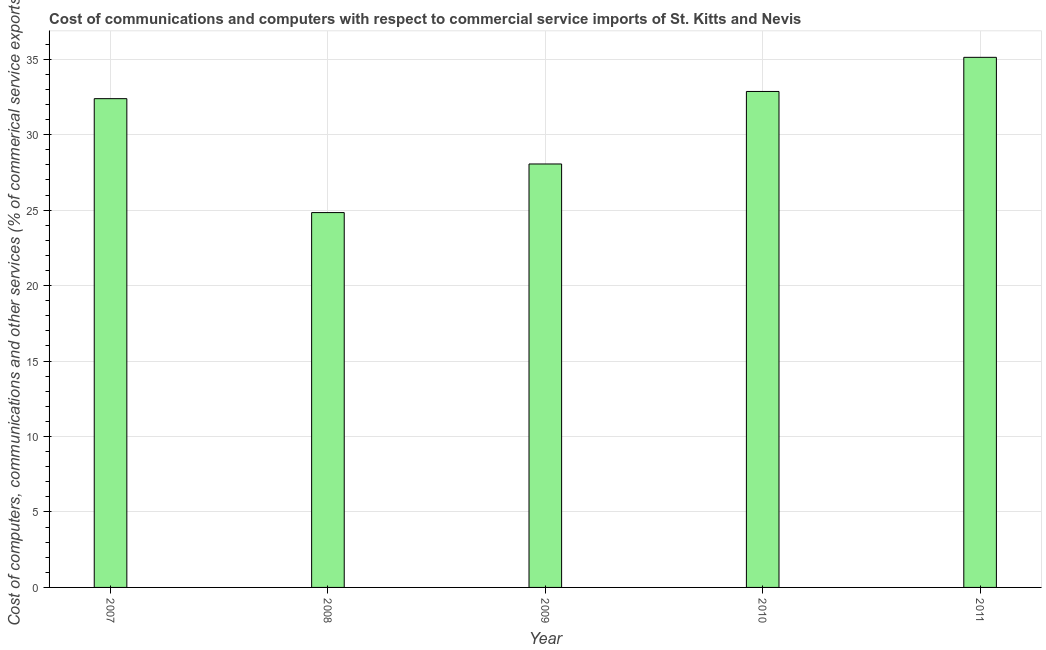What is the title of the graph?
Give a very brief answer. Cost of communications and computers with respect to commercial service imports of St. Kitts and Nevis. What is the label or title of the X-axis?
Your answer should be compact. Year. What is the label or title of the Y-axis?
Provide a succinct answer. Cost of computers, communications and other services (% of commerical service exports). What is the  computer and other services in 2011?
Make the answer very short. 35.12. Across all years, what is the maximum  computer and other services?
Give a very brief answer. 35.12. Across all years, what is the minimum  computer and other services?
Offer a very short reply. 24.84. In which year was the  computer and other services minimum?
Your answer should be compact. 2008. What is the sum of the  computer and other services?
Your answer should be very brief. 153.25. What is the difference between the cost of communications in 2008 and 2011?
Your response must be concise. -10.29. What is the average cost of communications per year?
Offer a terse response. 30.65. What is the median cost of communications?
Provide a short and direct response. 32.38. In how many years, is the  computer and other services greater than 24 %?
Your response must be concise. 5. What is the ratio of the  computer and other services in 2008 to that in 2011?
Make the answer very short. 0.71. Is the difference between the  computer and other services in 2008 and 2011 greater than the difference between any two years?
Keep it short and to the point. Yes. What is the difference between the highest and the second highest cost of communications?
Ensure brevity in your answer.  2.26. What is the difference between the highest and the lowest cost of communications?
Your answer should be compact. 10.29. How many bars are there?
Your answer should be compact. 5. Are all the bars in the graph horizontal?
Make the answer very short. No. How many years are there in the graph?
Keep it short and to the point. 5. What is the difference between two consecutive major ticks on the Y-axis?
Provide a short and direct response. 5. Are the values on the major ticks of Y-axis written in scientific E-notation?
Offer a very short reply. No. What is the Cost of computers, communications and other services (% of commerical service exports) of 2007?
Your answer should be compact. 32.38. What is the Cost of computers, communications and other services (% of commerical service exports) of 2008?
Your answer should be very brief. 24.84. What is the Cost of computers, communications and other services (% of commerical service exports) in 2009?
Give a very brief answer. 28.06. What is the Cost of computers, communications and other services (% of commerical service exports) in 2010?
Ensure brevity in your answer.  32.86. What is the Cost of computers, communications and other services (% of commerical service exports) in 2011?
Provide a short and direct response. 35.12. What is the difference between the Cost of computers, communications and other services (% of commerical service exports) in 2007 and 2008?
Your answer should be very brief. 7.55. What is the difference between the Cost of computers, communications and other services (% of commerical service exports) in 2007 and 2009?
Give a very brief answer. 4.33. What is the difference between the Cost of computers, communications and other services (% of commerical service exports) in 2007 and 2010?
Your answer should be compact. -0.48. What is the difference between the Cost of computers, communications and other services (% of commerical service exports) in 2007 and 2011?
Your response must be concise. -2.74. What is the difference between the Cost of computers, communications and other services (% of commerical service exports) in 2008 and 2009?
Provide a short and direct response. -3.22. What is the difference between the Cost of computers, communications and other services (% of commerical service exports) in 2008 and 2010?
Provide a succinct answer. -8.03. What is the difference between the Cost of computers, communications and other services (% of commerical service exports) in 2008 and 2011?
Offer a very short reply. -10.29. What is the difference between the Cost of computers, communications and other services (% of commerical service exports) in 2009 and 2010?
Offer a very short reply. -4.8. What is the difference between the Cost of computers, communications and other services (% of commerical service exports) in 2009 and 2011?
Offer a very short reply. -7.07. What is the difference between the Cost of computers, communications and other services (% of commerical service exports) in 2010 and 2011?
Offer a terse response. -2.26. What is the ratio of the Cost of computers, communications and other services (% of commerical service exports) in 2007 to that in 2008?
Your response must be concise. 1.3. What is the ratio of the Cost of computers, communications and other services (% of commerical service exports) in 2007 to that in 2009?
Make the answer very short. 1.15. What is the ratio of the Cost of computers, communications and other services (% of commerical service exports) in 2007 to that in 2010?
Provide a short and direct response. 0.98. What is the ratio of the Cost of computers, communications and other services (% of commerical service exports) in 2007 to that in 2011?
Offer a very short reply. 0.92. What is the ratio of the Cost of computers, communications and other services (% of commerical service exports) in 2008 to that in 2009?
Provide a succinct answer. 0.89. What is the ratio of the Cost of computers, communications and other services (% of commerical service exports) in 2008 to that in 2010?
Your answer should be compact. 0.76. What is the ratio of the Cost of computers, communications and other services (% of commerical service exports) in 2008 to that in 2011?
Make the answer very short. 0.71. What is the ratio of the Cost of computers, communications and other services (% of commerical service exports) in 2009 to that in 2010?
Your answer should be compact. 0.85. What is the ratio of the Cost of computers, communications and other services (% of commerical service exports) in 2009 to that in 2011?
Your answer should be compact. 0.8. What is the ratio of the Cost of computers, communications and other services (% of commerical service exports) in 2010 to that in 2011?
Provide a succinct answer. 0.94. 